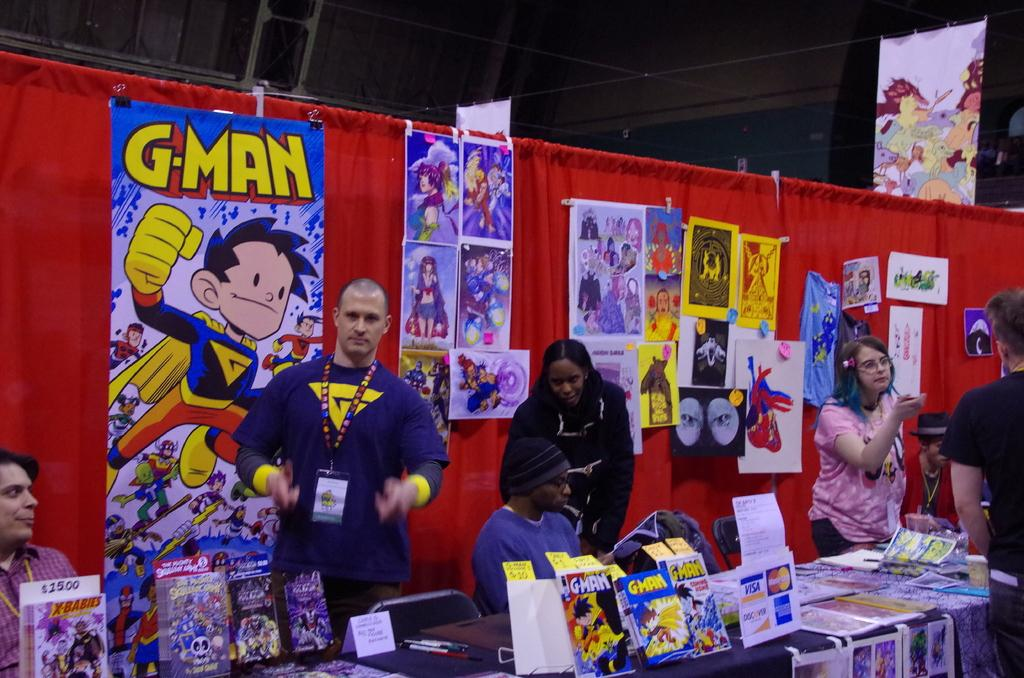<image>
Write a terse but informative summary of the picture. A stand about a cartoon or cartoon character called G-man. 